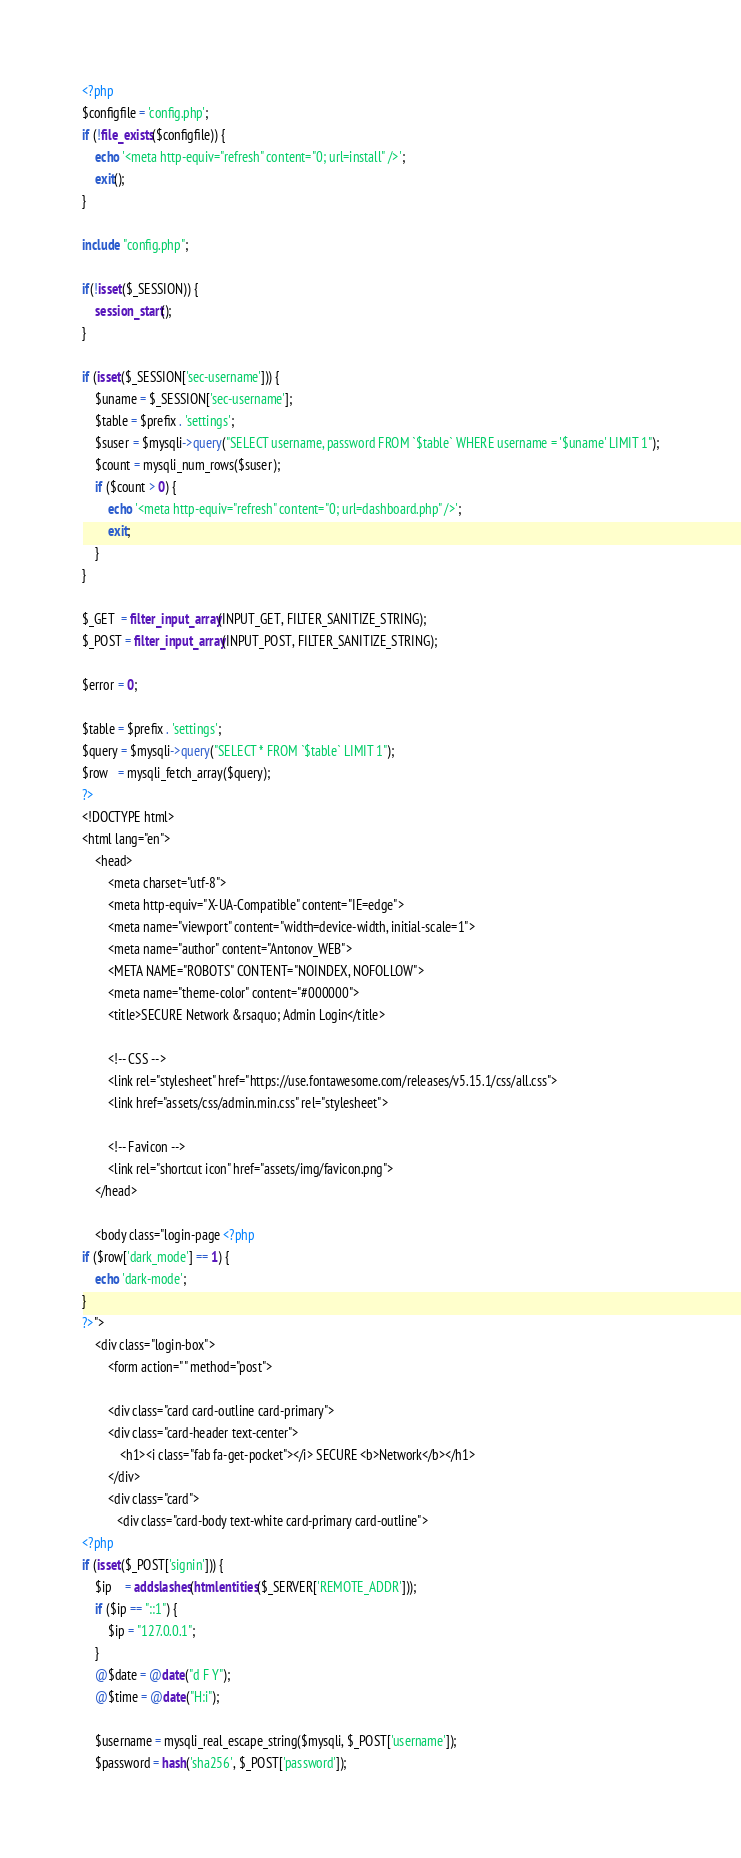Convert code to text. <code><loc_0><loc_0><loc_500><loc_500><_PHP_><?php
$configfile = 'config.php';
if (!file_exists($configfile)) {
    echo '<meta http-equiv="refresh" content="0; url=install" />';
    exit();
}

include "config.php";

if(!isset($_SESSION)) {
    session_start();
}

if (isset($_SESSION['sec-username'])) {
    $uname = $_SESSION['sec-username'];
    $table = $prefix . 'settings';
    $suser = $mysqli->query("SELECT username, password FROM `$table` WHERE username = '$uname' LIMIT 1");
    $count = mysqli_num_rows($suser);
    if ($count > 0) {
        echo '<meta http-equiv="refresh" content="0; url=dashboard.php" />';
        exit;
    }
}

$_GET  = filter_input_array(INPUT_GET, FILTER_SANITIZE_STRING);
$_POST = filter_input_array(INPUT_POST, FILTER_SANITIZE_STRING);

$error = 0;

$table = $prefix . 'settings';
$query = $mysqli->query("SELECT * FROM `$table` LIMIT 1");
$row   = mysqli_fetch_array($query);
?>
<!DOCTYPE html>
<html lang="en">
    <head>
        <meta charset="utf-8">
        <meta http-equiv="X-UA-Compatible" content="IE=edge">
        <meta name="viewport" content="width=device-width, initial-scale=1">
		<meta name="author" content="Antonov_WEB">
        <META NAME="ROBOTS" CONTENT="NOINDEX, NOFOLLOW">
		<meta name="theme-color" content="#000000">
        <title>SECURE Network &rsaquo; Admin Login</title>

        <!-- CSS -->
        <link rel="stylesheet" href="https://use.fontawesome.com/releases/v5.15.1/css/all.css">
		<link href="assets/css/admin.min.css" rel="stylesheet">

        <!-- Favicon -->
        <link rel="shortcut icon" href="assets/img/favicon.png">
    </head>

    <body class="login-page <?php
if ($row['dark_mode'] == 1) {
    echo 'dark-mode';
}
?>">
	<div class="login-box">
	    <form action="" method="post">

		<div class="card card-outline card-primary">
		<div class="card-header text-center">
			<h1><i class="fab fa-get-pocket"></i> SECURE <b>Network</b></h1>
		</div>
		<div class="card">
           <div class="card-body text-white card-primary card-outline">
<?php
if (isset($_POST['signin'])) {
    $ip    = addslashes(htmlentities($_SERVER['REMOTE_ADDR']));
	if ($ip == "::1") {
		$ip = "127.0.0.1";
	}
	@$date = @date("d F Y");
    @$time = @date("H:i");
    
    $username = mysqli_real_escape_string($mysqli, $_POST['username']);
    $password = hash('sha256', $_POST['password']);</code> 